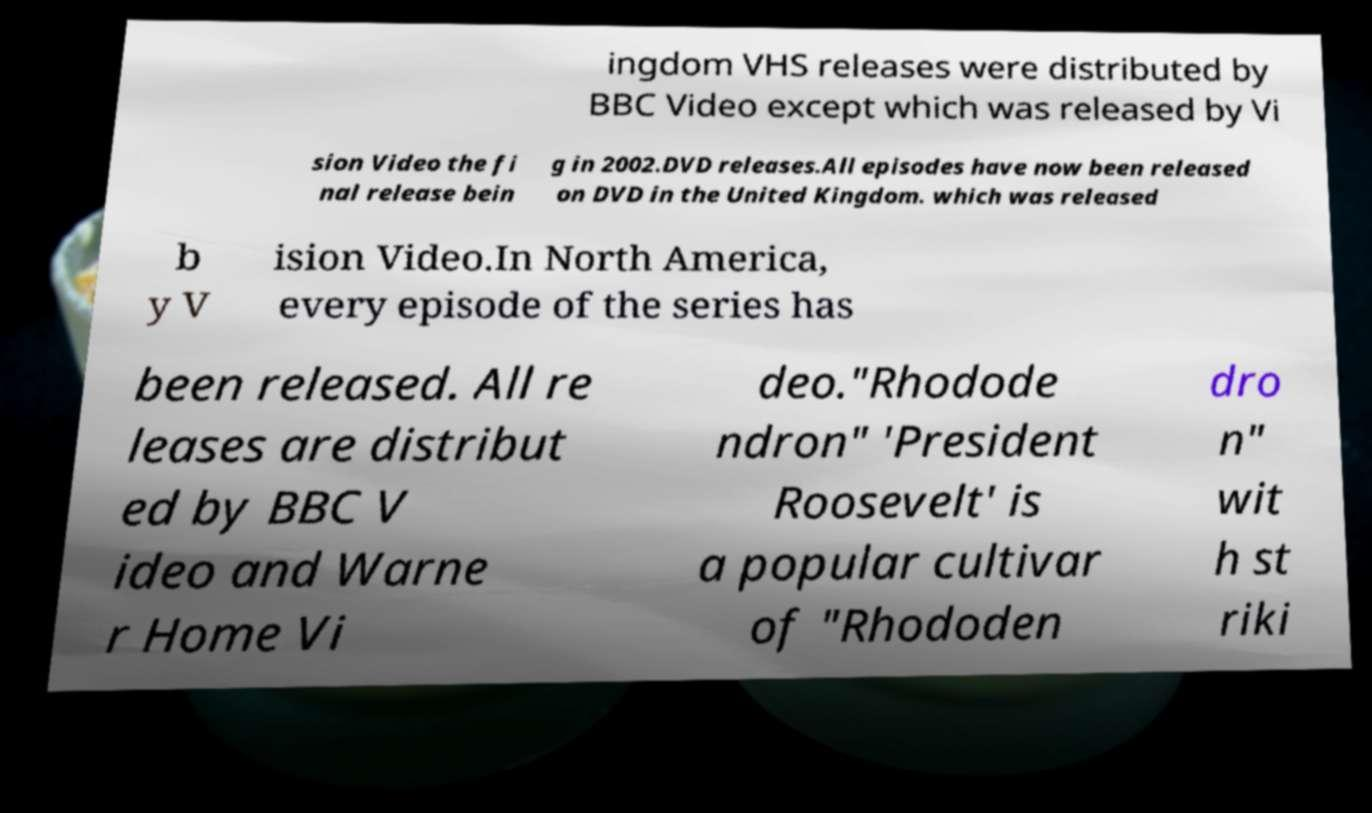Can you accurately transcribe the text from the provided image for me? ingdom VHS releases were distributed by BBC Video except which was released by Vi sion Video the fi nal release bein g in 2002.DVD releases.All episodes have now been released on DVD in the United Kingdom. which was released b y V ision Video.In North America, every episode of the series has been released. All re leases are distribut ed by BBC V ideo and Warne r Home Vi deo."Rhodode ndron" 'President Roosevelt' is a popular cultivar of "Rhododen dro n" wit h st riki 